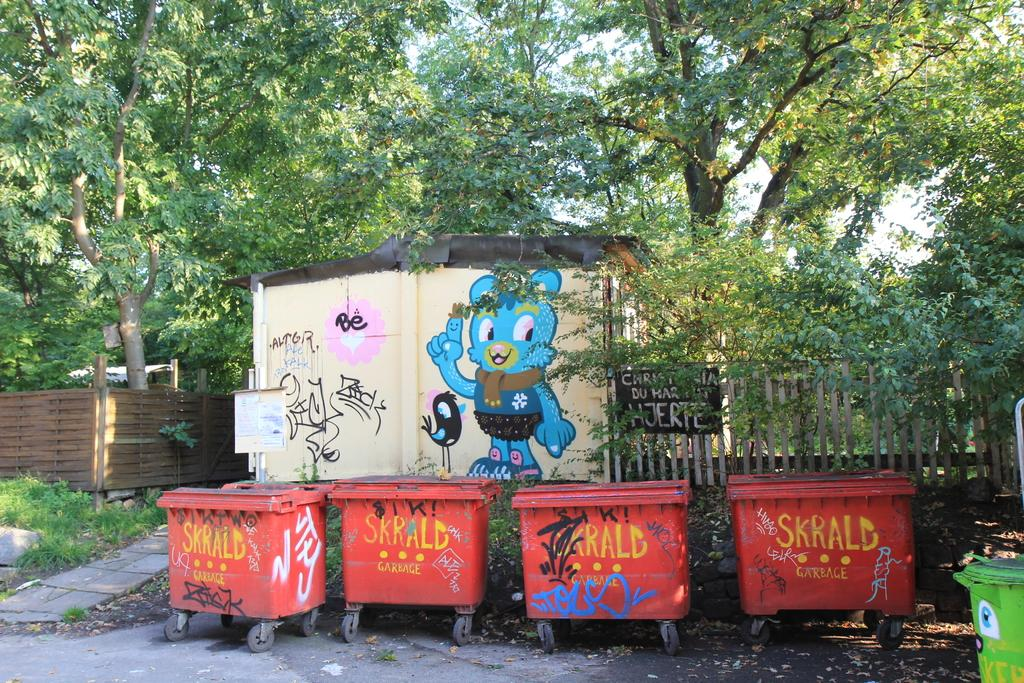<image>
Give a short and clear explanation of the subsequent image. several orange garbage bins read SKRALD on them 